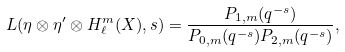Convert formula to latex. <formula><loc_0><loc_0><loc_500><loc_500>L ( \eta \otimes \eta ^ { \prime } \otimes H _ { \ell } ^ { m } ( X ) , s ) = \frac { P _ { 1 , m } ( q ^ { - s } ) } { P _ { 0 , m } ( q ^ { - s } ) P _ { 2 , m } ( q ^ { - s } ) } ,</formula> 